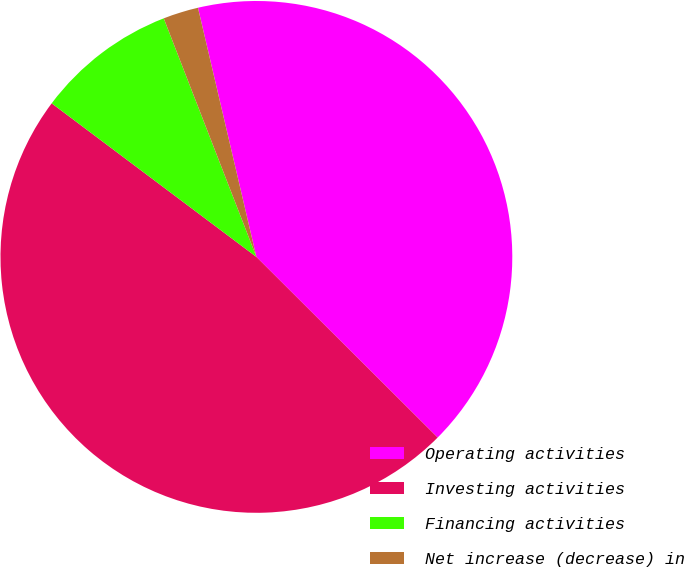Convert chart to OTSL. <chart><loc_0><loc_0><loc_500><loc_500><pie_chart><fcel>Operating activities<fcel>Investing activities<fcel>Financing activities<fcel>Net increase (decrease) in<nl><fcel>41.14%<fcel>47.77%<fcel>8.86%<fcel>2.23%<nl></chart> 